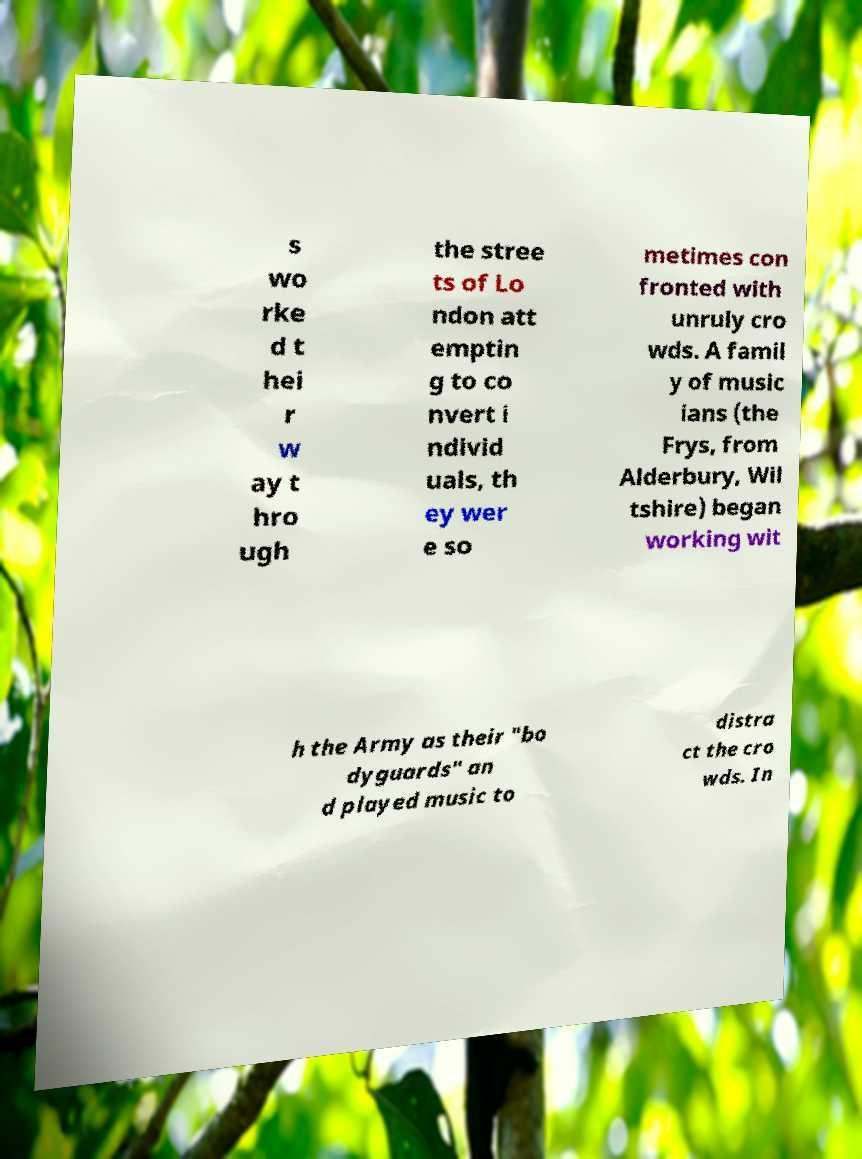For documentation purposes, I need the text within this image transcribed. Could you provide that? s wo rke d t hei r w ay t hro ugh the stree ts of Lo ndon att emptin g to co nvert i ndivid uals, th ey wer e so metimes con fronted with unruly cro wds. A famil y of music ians (the Frys, from Alderbury, Wil tshire) began working wit h the Army as their "bo dyguards" an d played music to distra ct the cro wds. In 